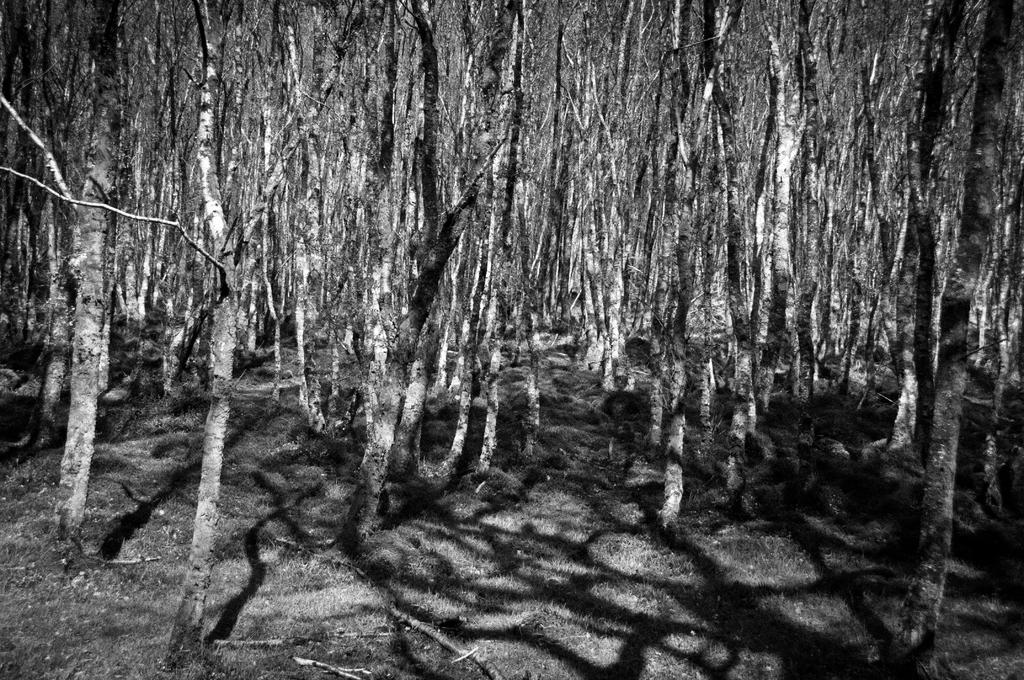What is the color scheme of the image? The image is black and white. What type of vegetation can be seen in the image? There is a group of trees in the image. What else can be seen on the ground in the image? There is grass visible in the image. What type of furniture is present in the image? There is no furniture present in the image; it primarily features a group of trees and grass. What activity is taking place in the image? The image does not depict any specific activity; it is a still scene of trees and grass. 